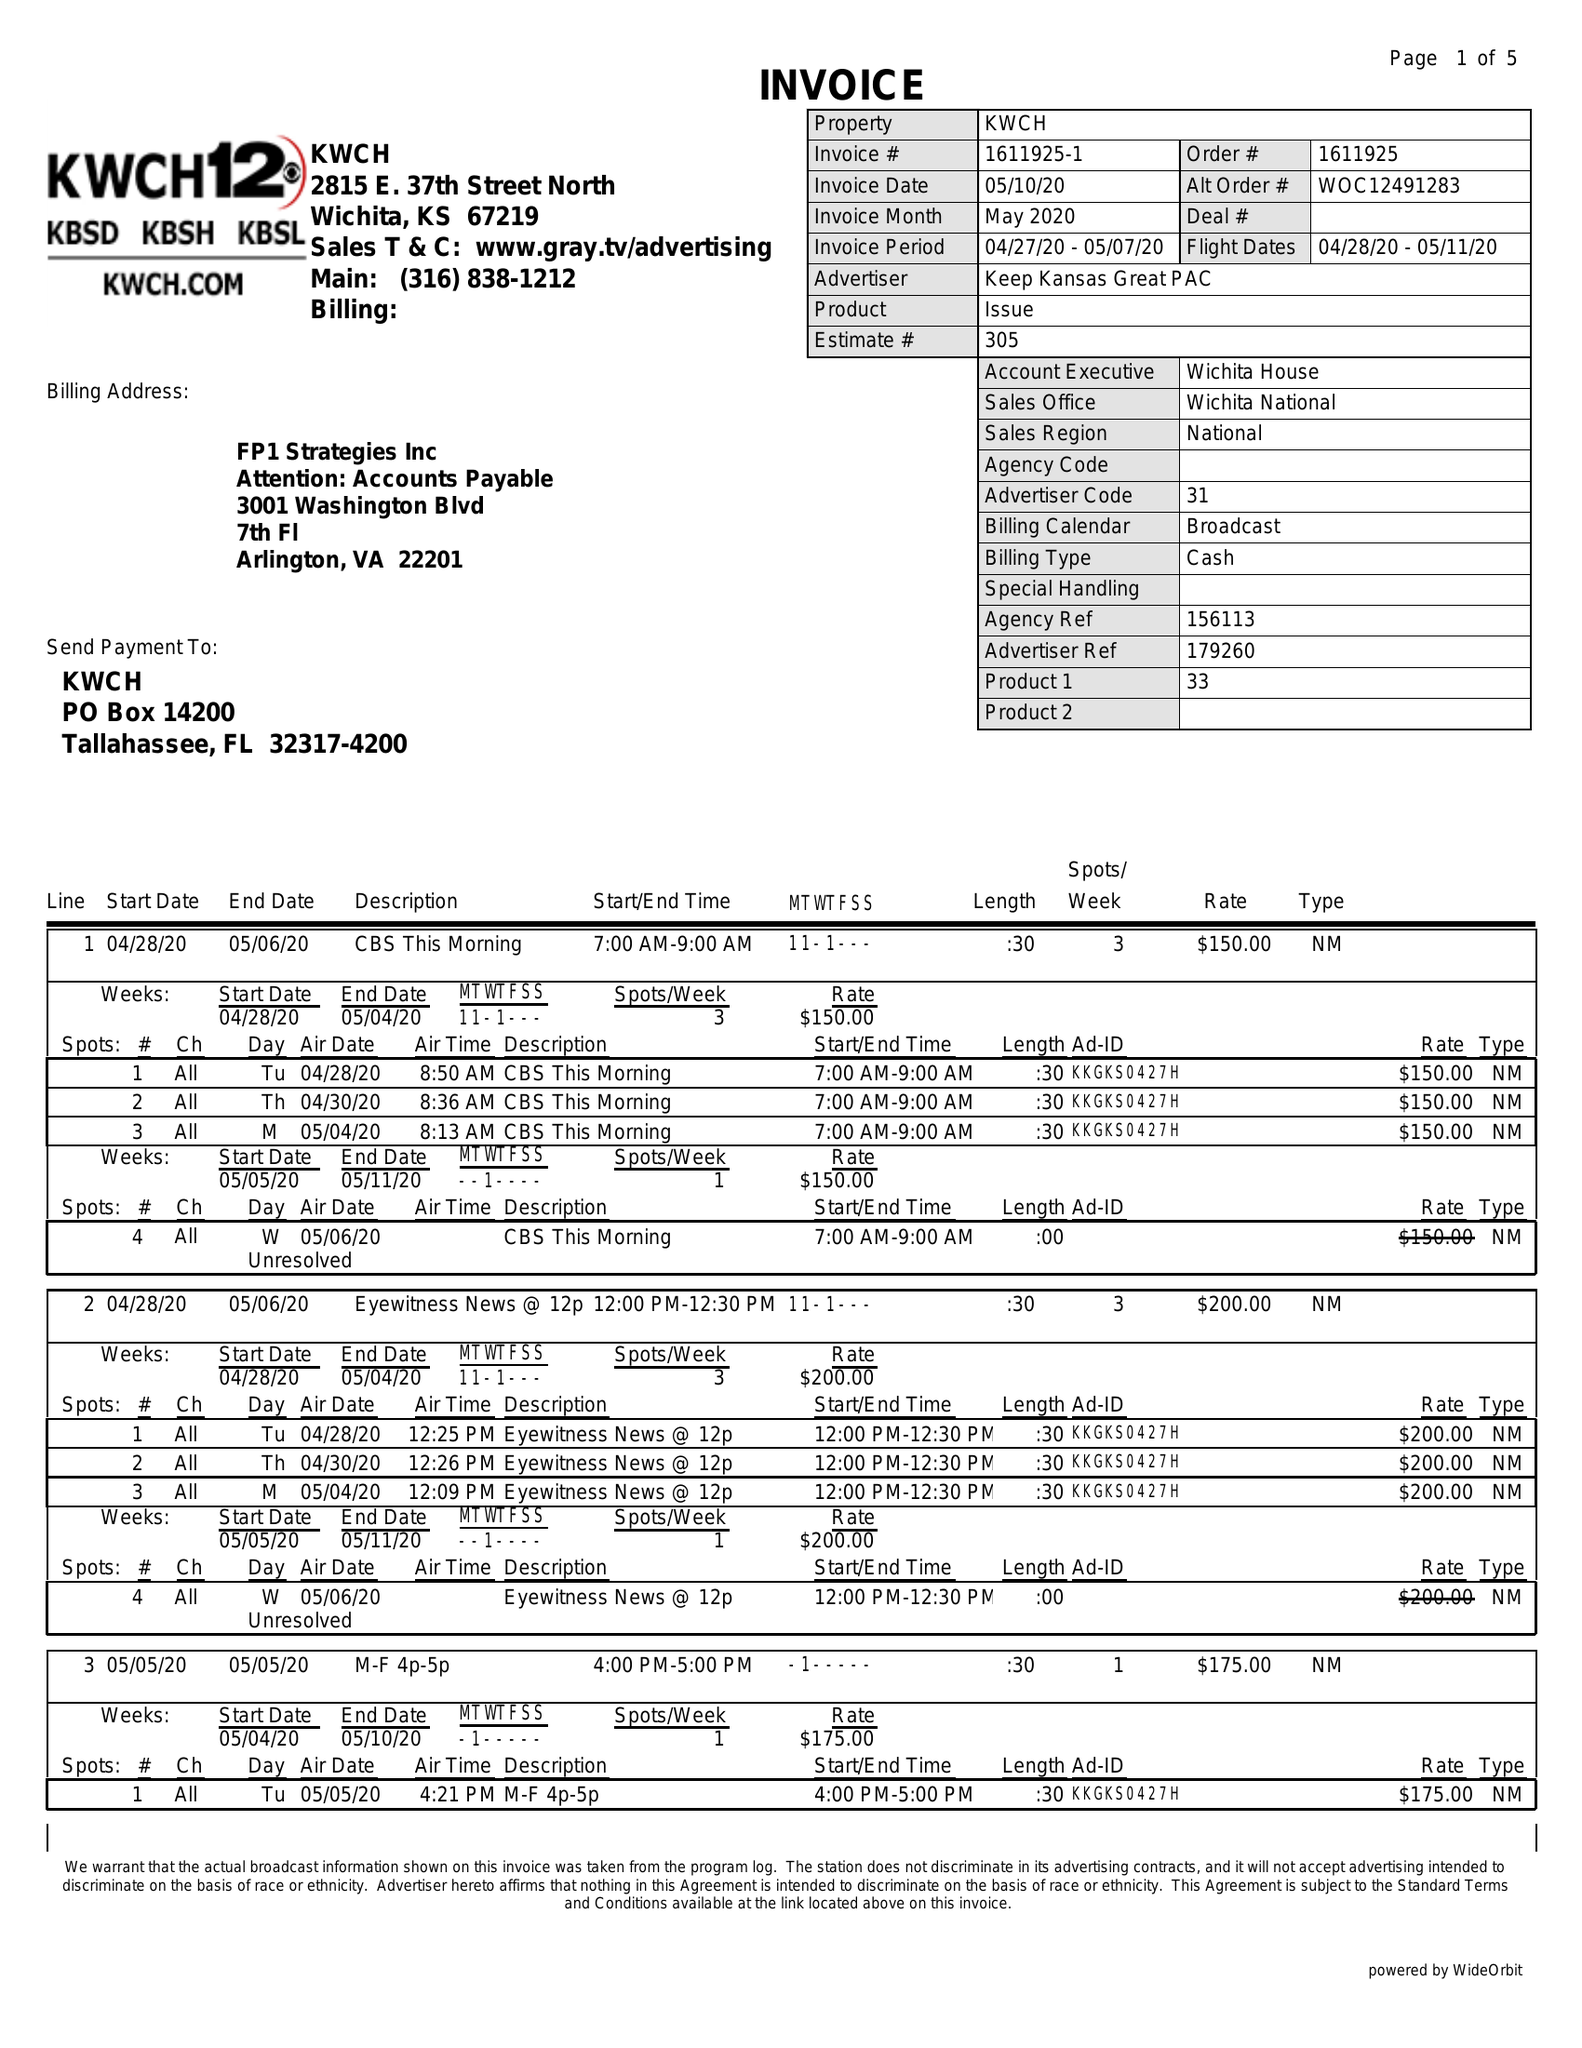What is the value for the gross_amount?
Answer the question using a single word or phrase. 10965.00 